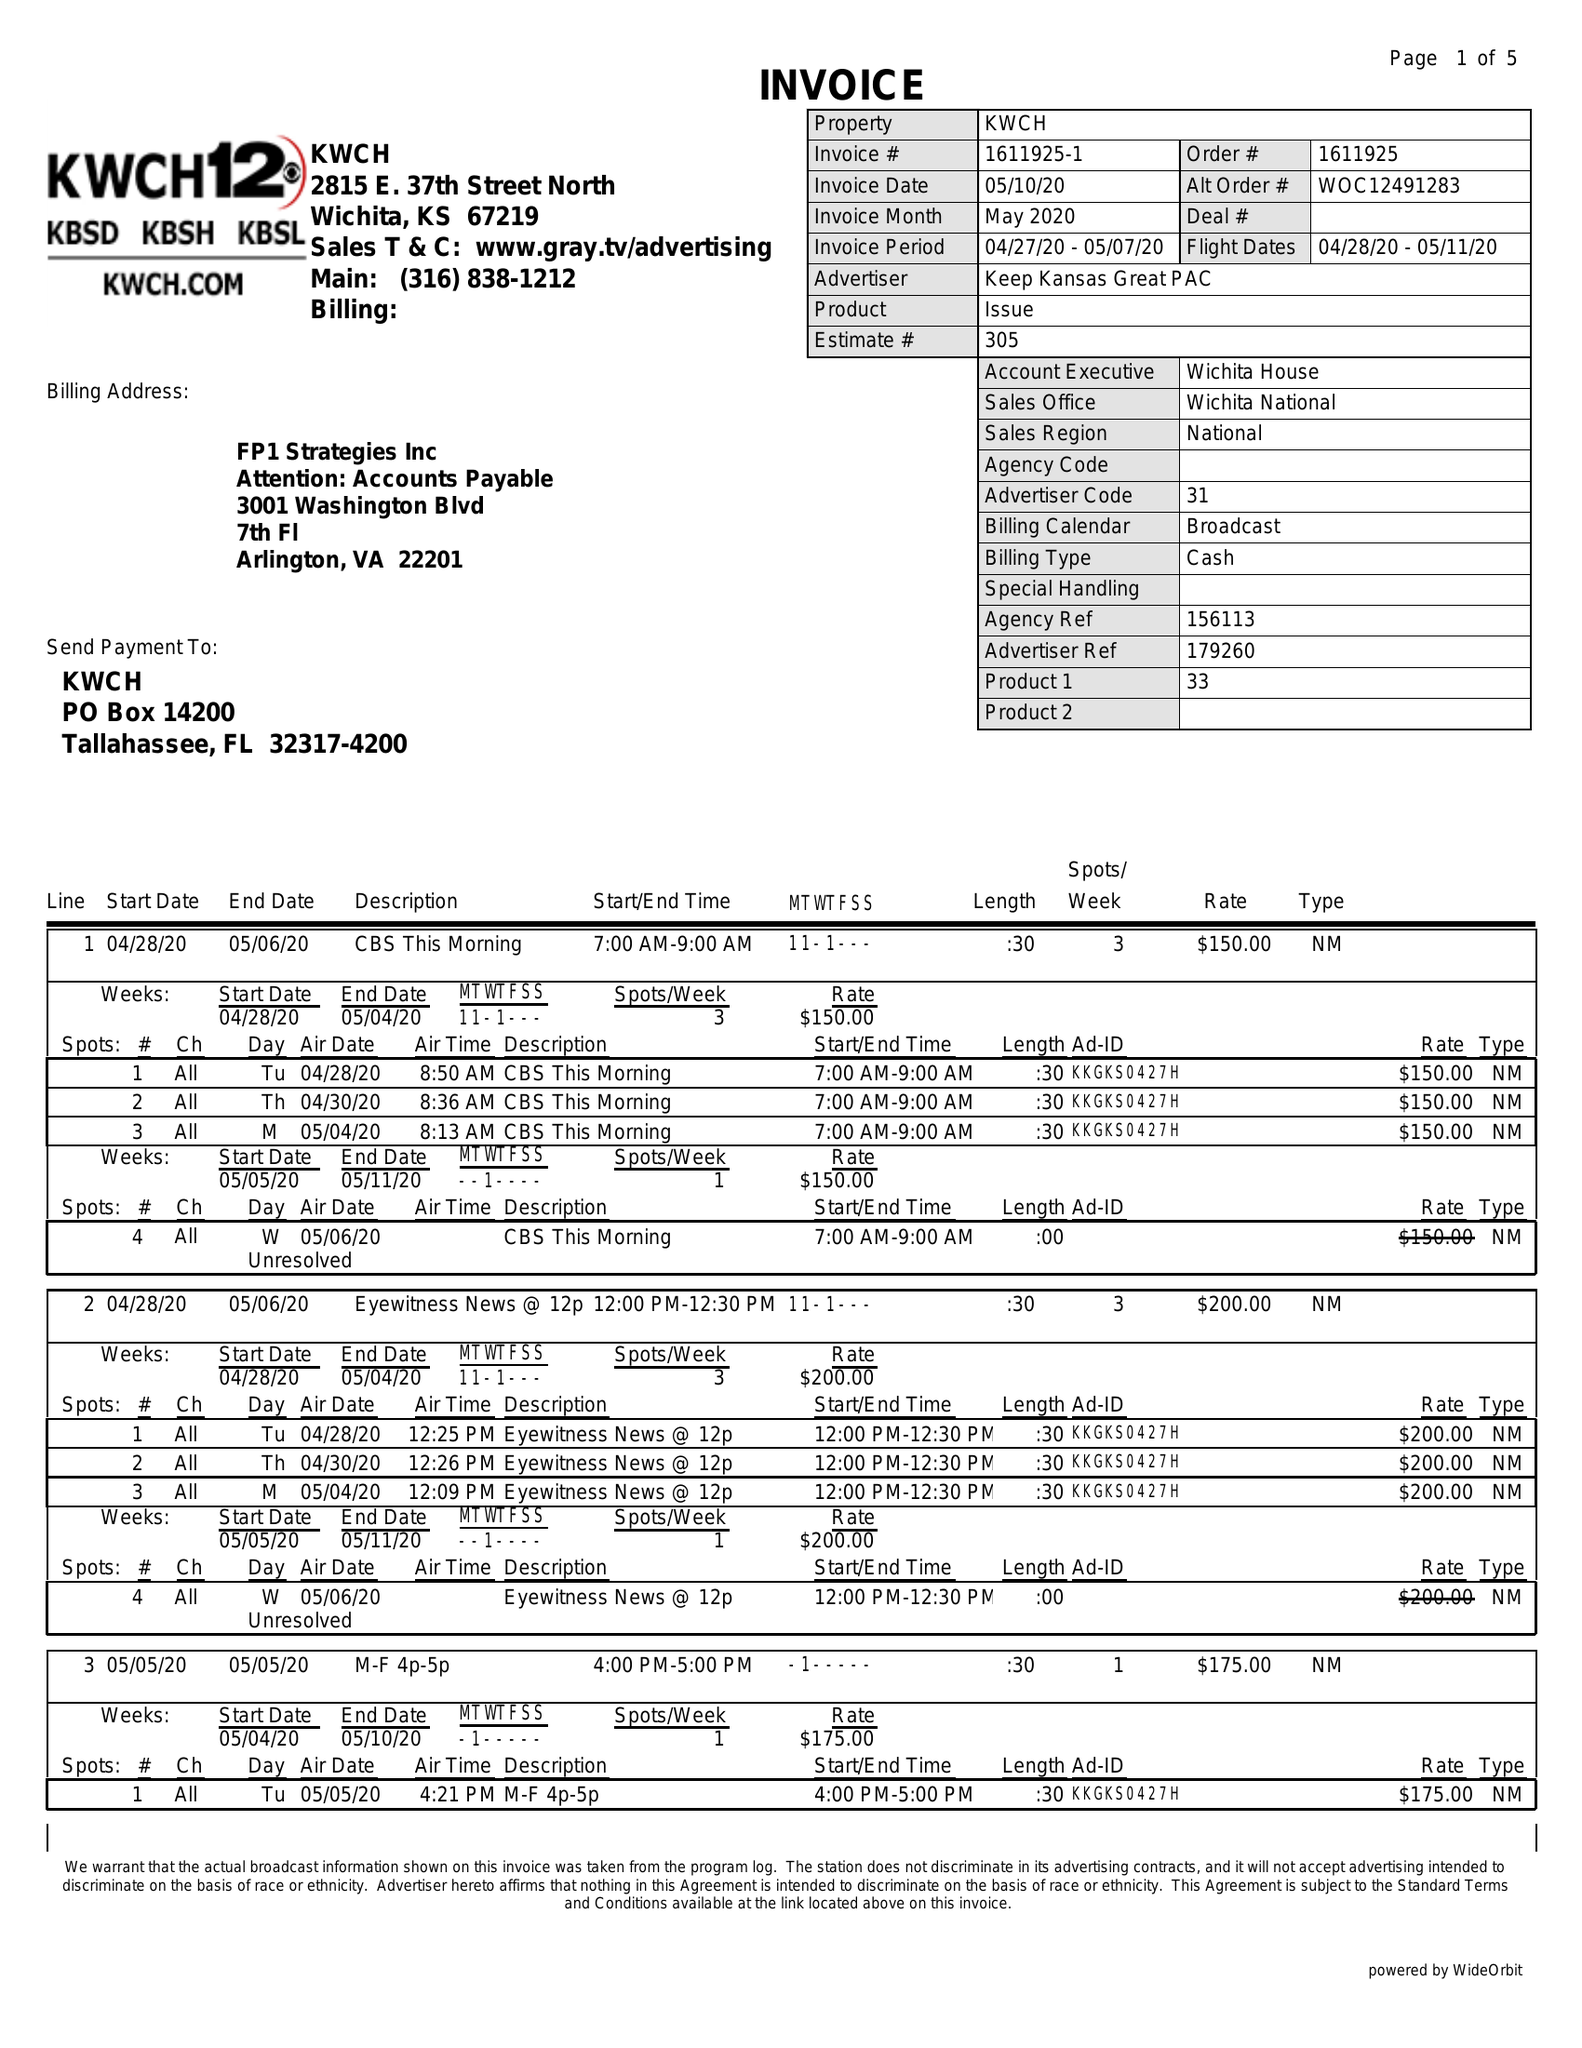What is the value for the gross_amount?
Answer the question using a single word or phrase. 10965.00 